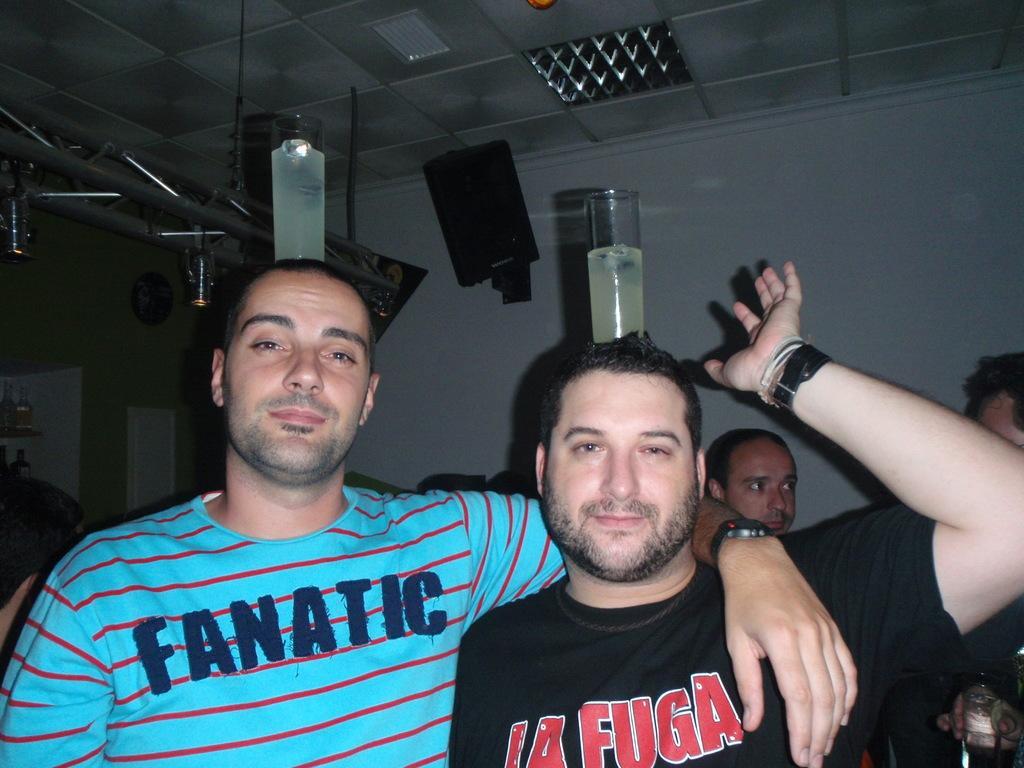Could you give a brief overview of what you see in this image? In the image there are two men standing. There are glasses with liquids on their heads. Behind them there are few people standing. There is a wall with speaker and there are rods. At the top of the image there is a ceiling with lights. On the left side of the image there is a cupboard with bottles. 